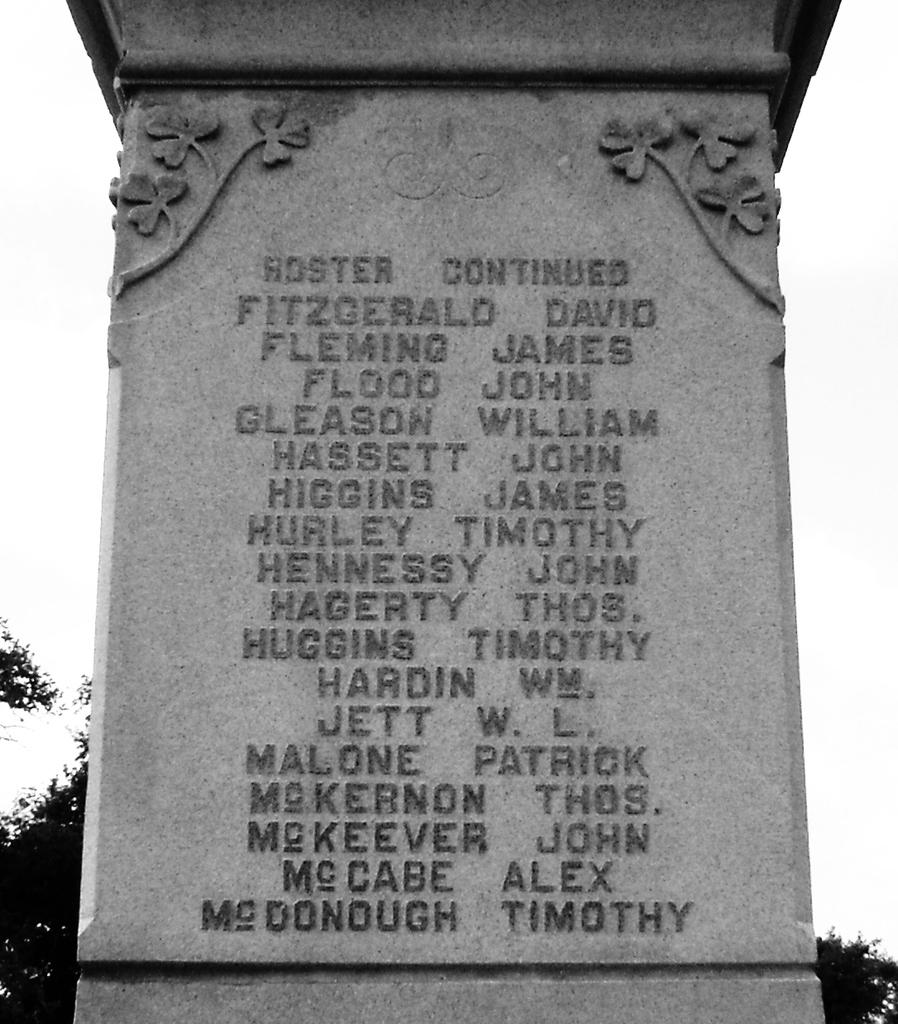What is the color scheme of the image? The image is black and white. What type of object can be seen on the ground in the image? There is a laid stone in the image. What type of natural elements are present in the image? There are trees in the image. What is visible in the background of the image? The sky is visible in the image. Where is the hydrant located in the image? There is no hydrant present in the image. What type of flame can be seen coming from the trees in the image? There is no flame present in the image; it is a black and white image with trees and a laid stone. 